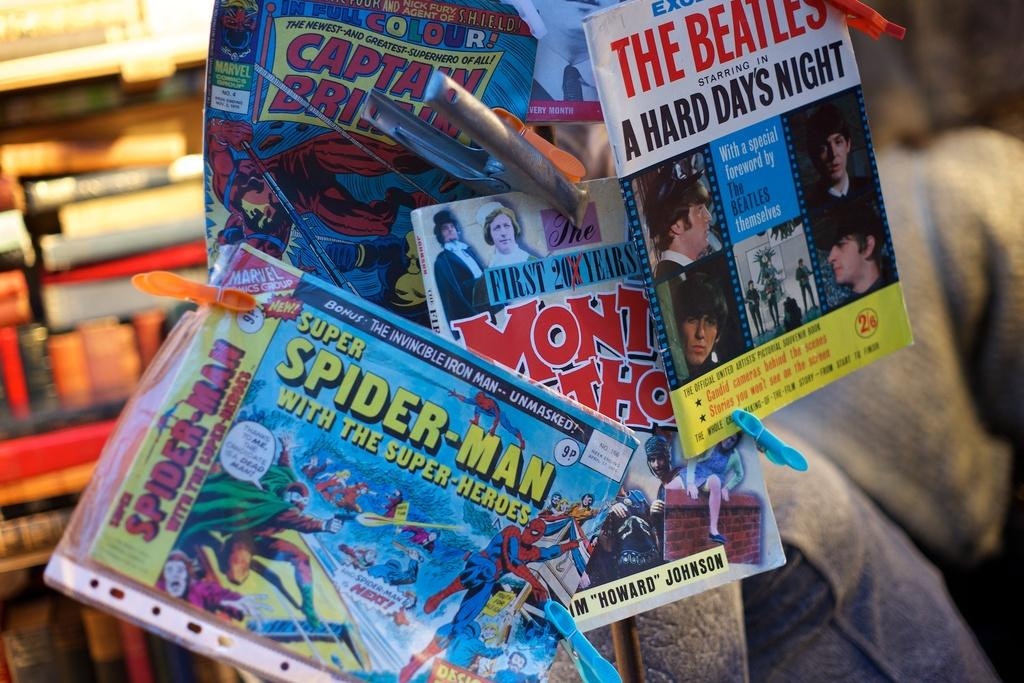<image>
Give a short and clear explanation of the subsequent image. spiderman magazines or comics with other comics in hand 